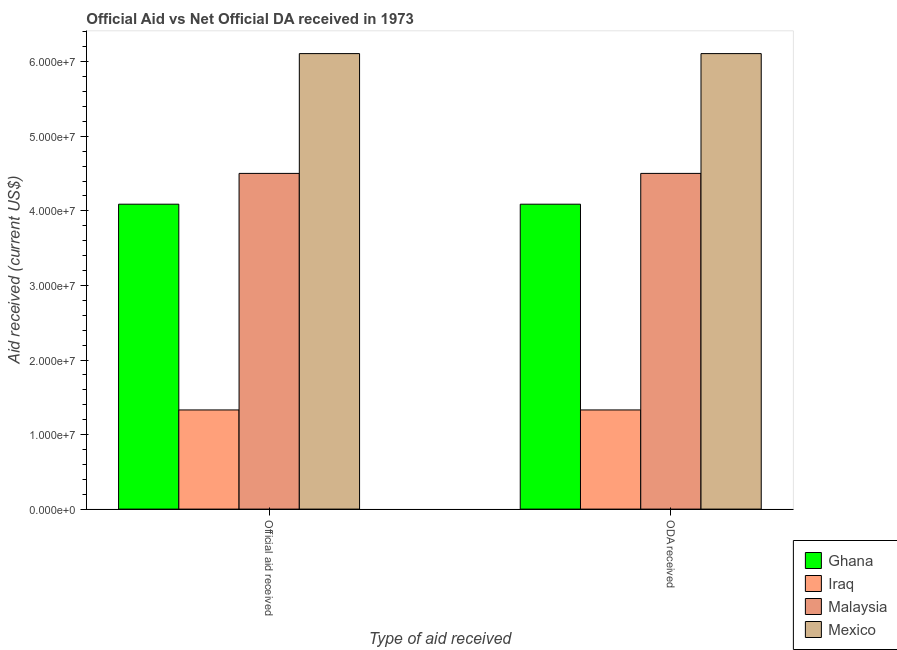Are the number of bars per tick equal to the number of legend labels?
Your answer should be very brief. Yes. Are the number of bars on each tick of the X-axis equal?
Offer a terse response. Yes. What is the label of the 2nd group of bars from the left?
Keep it short and to the point. ODA received. What is the official aid received in Ghana?
Keep it short and to the point. 4.09e+07. Across all countries, what is the maximum official aid received?
Offer a very short reply. 6.11e+07. Across all countries, what is the minimum official aid received?
Provide a succinct answer. 1.33e+07. In which country was the official aid received minimum?
Provide a short and direct response. Iraq. What is the total official aid received in the graph?
Keep it short and to the point. 1.60e+08. What is the difference between the oda received in Malaysia and that in Mexico?
Provide a succinct answer. -1.61e+07. What is the difference between the oda received in Mexico and the official aid received in Iraq?
Make the answer very short. 4.78e+07. What is the average official aid received per country?
Give a very brief answer. 4.01e+07. What is the difference between the official aid received and oda received in Ghana?
Keep it short and to the point. 0. What is the ratio of the oda received in Mexico to that in Iraq?
Give a very brief answer. 4.59. Is the oda received in Ghana less than that in Mexico?
Give a very brief answer. Yes. In how many countries, is the official aid received greater than the average official aid received taken over all countries?
Your answer should be very brief. 3. What does the 3rd bar from the left in ODA received represents?
Your response must be concise. Malaysia. What does the 3rd bar from the right in ODA received represents?
Provide a succinct answer. Iraq. How many bars are there?
Provide a succinct answer. 8. What is the difference between two consecutive major ticks on the Y-axis?
Offer a very short reply. 1.00e+07. How many legend labels are there?
Your answer should be compact. 4. How are the legend labels stacked?
Provide a succinct answer. Vertical. What is the title of the graph?
Offer a very short reply. Official Aid vs Net Official DA received in 1973 . What is the label or title of the X-axis?
Make the answer very short. Type of aid received. What is the label or title of the Y-axis?
Make the answer very short. Aid received (current US$). What is the Aid received (current US$) of Ghana in Official aid received?
Your response must be concise. 4.09e+07. What is the Aid received (current US$) of Iraq in Official aid received?
Offer a terse response. 1.33e+07. What is the Aid received (current US$) of Malaysia in Official aid received?
Your answer should be very brief. 4.50e+07. What is the Aid received (current US$) of Mexico in Official aid received?
Provide a short and direct response. 6.11e+07. What is the Aid received (current US$) of Ghana in ODA received?
Ensure brevity in your answer.  4.09e+07. What is the Aid received (current US$) in Iraq in ODA received?
Provide a succinct answer. 1.33e+07. What is the Aid received (current US$) of Malaysia in ODA received?
Offer a very short reply. 4.50e+07. What is the Aid received (current US$) in Mexico in ODA received?
Keep it short and to the point. 6.11e+07. Across all Type of aid received, what is the maximum Aid received (current US$) of Ghana?
Your answer should be compact. 4.09e+07. Across all Type of aid received, what is the maximum Aid received (current US$) of Iraq?
Your response must be concise. 1.33e+07. Across all Type of aid received, what is the maximum Aid received (current US$) of Malaysia?
Your response must be concise. 4.50e+07. Across all Type of aid received, what is the maximum Aid received (current US$) of Mexico?
Ensure brevity in your answer.  6.11e+07. Across all Type of aid received, what is the minimum Aid received (current US$) in Ghana?
Offer a terse response. 4.09e+07. Across all Type of aid received, what is the minimum Aid received (current US$) in Iraq?
Keep it short and to the point. 1.33e+07. Across all Type of aid received, what is the minimum Aid received (current US$) in Malaysia?
Your answer should be compact. 4.50e+07. Across all Type of aid received, what is the minimum Aid received (current US$) of Mexico?
Offer a terse response. 6.11e+07. What is the total Aid received (current US$) of Ghana in the graph?
Ensure brevity in your answer.  8.18e+07. What is the total Aid received (current US$) of Iraq in the graph?
Offer a very short reply. 2.66e+07. What is the total Aid received (current US$) in Malaysia in the graph?
Make the answer very short. 9.01e+07. What is the total Aid received (current US$) of Mexico in the graph?
Ensure brevity in your answer.  1.22e+08. What is the difference between the Aid received (current US$) in Ghana in Official aid received and that in ODA received?
Your response must be concise. 0. What is the difference between the Aid received (current US$) in Iraq in Official aid received and that in ODA received?
Make the answer very short. 0. What is the difference between the Aid received (current US$) of Malaysia in Official aid received and that in ODA received?
Your answer should be compact. 0. What is the difference between the Aid received (current US$) in Mexico in Official aid received and that in ODA received?
Your response must be concise. 0. What is the difference between the Aid received (current US$) of Ghana in Official aid received and the Aid received (current US$) of Iraq in ODA received?
Offer a terse response. 2.76e+07. What is the difference between the Aid received (current US$) in Ghana in Official aid received and the Aid received (current US$) in Malaysia in ODA received?
Keep it short and to the point. -4.13e+06. What is the difference between the Aid received (current US$) in Ghana in Official aid received and the Aid received (current US$) in Mexico in ODA received?
Offer a terse response. -2.02e+07. What is the difference between the Aid received (current US$) of Iraq in Official aid received and the Aid received (current US$) of Malaysia in ODA received?
Your answer should be very brief. -3.17e+07. What is the difference between the Aid received (current US$) of Iraq in Official aid received and the Aid received (current US$) of Mexico in ODA received?
Offer a terse response. -4.78e+07. What is the difference between the Aid received (current US$) of Malaysia in Official aid received and the Aid received (current US$) of Mexico in ODA received?
Give a very brief answer. -1.61e+07. What is the average Aid received (current US$) of Ghana per Type of aid received?
Your response must be concise. 4.09e+07. What is the average Aid received (current US$) in Iraq per Type of aid received?
Give a very brief answer. 1.33e+07. What is the average Aid received (current US$) in Malaysia per Type of aid received?
Ensure brevity in your answer.  4.50e+07. What is the average Aid received (current US$) of Mexico per Type of aid received?
Give a very brief answer. 6.11e+07. What is the difference between the Aid received (current US$) in Ghana and Aid received (current US$) in Iraq in Official aid received?
Ensure brevity in your answer.  2.76e+07. What is the difference between the Aid received (current US$) in Ghana and Aid received (current US$) in Malaysia in Official aid received?
Give a very brief answer. -4.13e+06. What is the difference between the Aid received (current US$) in Ghana and Aid received (current US$) in Mexico in Official aid received?
Offer a very short reply. -2.02e+07. What is the difference between the Aid received (current US$) in Iraq and Aid received (current US$) in Malaysia in Official aid received?
Ensure brevity in your answer.  -3.17e+07. What is the difference between the Aid received (current US$) in Iraq and Aid received (current US$) in Mexico in Official aid received?
Your answer should be very brief. -4.78e+07. What is the difference between the Aid received (current US$) of Malaysia and Aid received (current US$) of Mexico in Official aid received?
Provide a succinct answer. -1.61e+07. What is the difference between the Aid received (current US$) in Ghana and Aid received (current US$) in Iraq in ODA received?
Provide a short and direct response. 2.76e+07. What is the difference between the Aid received (current US$) of Ghana and Aid received (current US$) of Malaysia in ODA received?
Give a very brief answer. -4.13e+06. What is the difference between the Aid received (current US$) of Ghana and Aid received (current US$) of Mexico in ODA received?
Make the answer very short. -2.02e+07. What is the difference between the Aid received (current US$) of Iraq and Aid received (current US$) of Malaysia in ODA received?
Make the answer very short. -3.17e+07. What is the difference between the Aid received (current US$) in Iraq and Aid received (current US$) in Mexico in ODA received?
Make the answer very short. -4.78e+07. What is the difference between the Aid received (current US$) of Malaysia and Aid received (current US$) of Mexico in ODA received?
Offer a very short reply. -1.61e+07. What is the ratio of the Aid received (current US$) in Ghana in Official aid received to that in ODA received?
Provide a short and direct response. 1. What is the ratio of the Aid received (current US$) of Mexico in Official aid received to that in ODA received?
Keep it short and to the point. 1. What is the difference between the highest and the second highest Aid received (current US$) in Ghana?
Your answer should be compact. 0. What is the difference between the highest and the second highest Aid received (current US$) of Mexico?
Your answer should be compact. 0. What is the difference between the highest and the lowest Aid received (current US$) in Ghana?
Give a very brief answer. 0. What is the difference between the highest and the lowest Aid received (current US$) of Iraq?
Give a very brief answer. 0. What is the difference between the highest and the lowest Aid received (current US$) of Malaysia?
Provide a short and direct response. 0. 